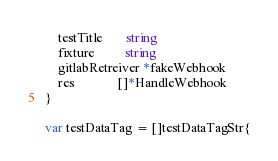Convert code to text. <code><loc_0><loc_0><loc_500><loc_500><_Go_>	testTitle       string
	fixture         string
	gitlabRetreiver *fakeWebhook
	res             []*HandleWebhook
}

var testDataTag = []testDataTagStr{</code> 